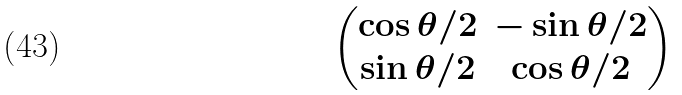<formula> <loc_0><loc_0><loc_500><loc_500>\begin{pmatrix} \cos \theta / 2 & - \sin \theta / 2 \\ \sin \theta / 2 & \cos \theta / 2 \\ \end{pmatrix}</formula> 